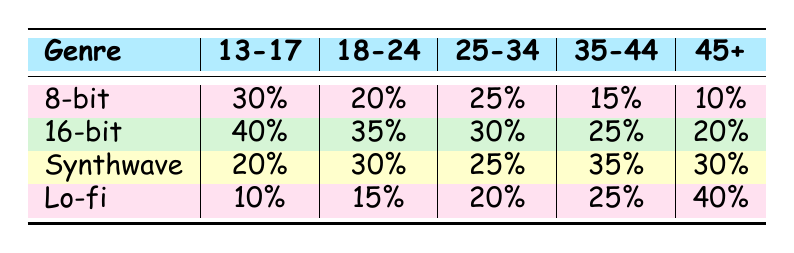What is the preferred genre for the age group 18-24? The table shows that for the age group 18-24, the preferred genre is 16-bit with a percentage of 35%.
Answer: 16-bit Which genre has the lowest preference among the 25-34 age group? In the 25-34 age group, the genre with the lowest preference is 8-bit, which has a percentage of 25%.
Answer: 8-bit What is the total percentage of preference for the Synthwave genre across all age groups? To find the total percentage of preference for Synthwave, we add the percentages across all age groups: 20 + 30 + 25 + 35 + 30 = 140.
Answer: 140 Do more people in the 35-44 age group prefer  Lo-fi than 8-bit? In the 35-44 age group, 25% prefer Lo-fi, while 15% prefer 8-bit. Since 25% is greater than 15%, the statement is true.
Answer: Yes Which age group shows the highest preference for 16-bit? The highest preference for 16-bit is found in the 13-17 age group, where it has a percentage of 40%.
Answer: 13-17 What is the average percentage for the 45+ age group across all genres? The percentages for the 45+ age group are 10, 20, 30, and 40. We sum these values: 10 + 20 + 30 + 40 = 100, then divide by the number of genres (4): 100 / 4 = 25.
Answer: 25 Is there a genre that is preferred equally between the 18-24 and 25-34 age groups? For both the 18-24 and 25-34 age groups, the percentage for Synthwave is the same at 25%, indicating an equal preference.
Answer: Yes What is the difference in preference for 8-bit between the 13-17 and 45+ age groups? The 13-17 age group has a preference of 30% for 8-bit, and the 45+ group has a preference of 10%. The difference is 30 - 10 = 20.
Answer: 20 Which genre has the highest overall preference in the table? To determine the highest overall preference, we compare the highest percentages from each age group: 8-bit (30%), 16-bit (40%), Synthwave (35%), and Lo-fi (40%). The highest preference is 40% for both 16-bit and Lo-fi.
Answer: 16-bit and Lo-fi 